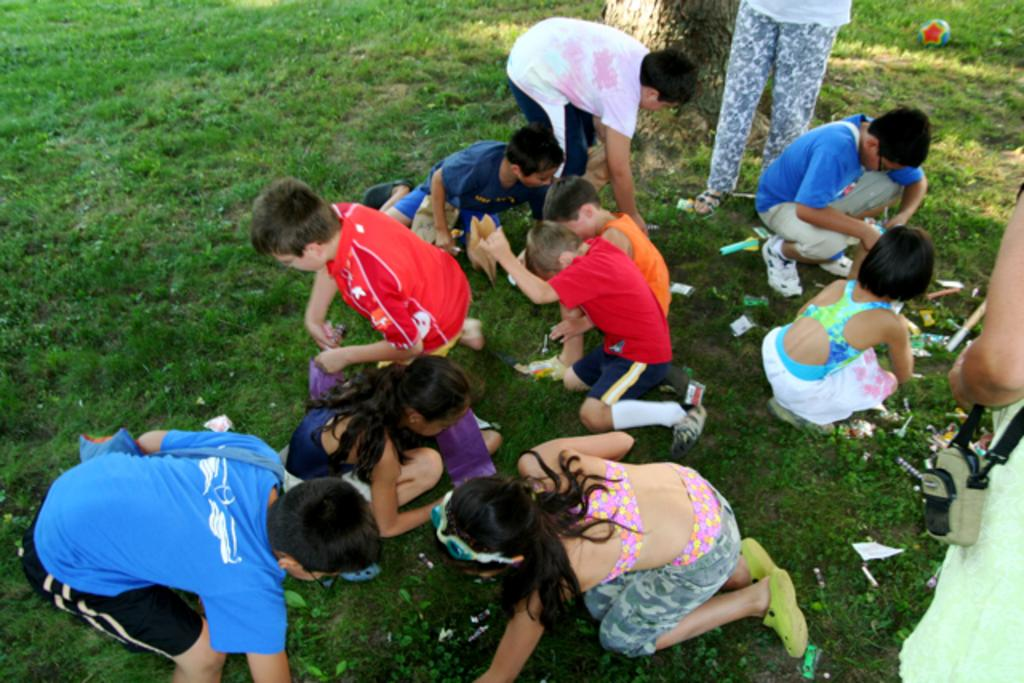What are the people in the image doing? The people in the image are sitting in the garden. How can you describe the attire of the people? The people are wearing different color dresses. Can you identify any accessories worn by the people? Yes, there is a person wearing a bag. What other object is present in the image? There is a ball in the image. How would you describe the appearance of the ball? The ball has different colors. What is the profit made by the celery in the image? There is no celery present in the image, so it is not possible to determine any profit made by it. 